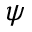<formula> <loc_0><loc_0><loc_500><loc_500>\psi</formula> 